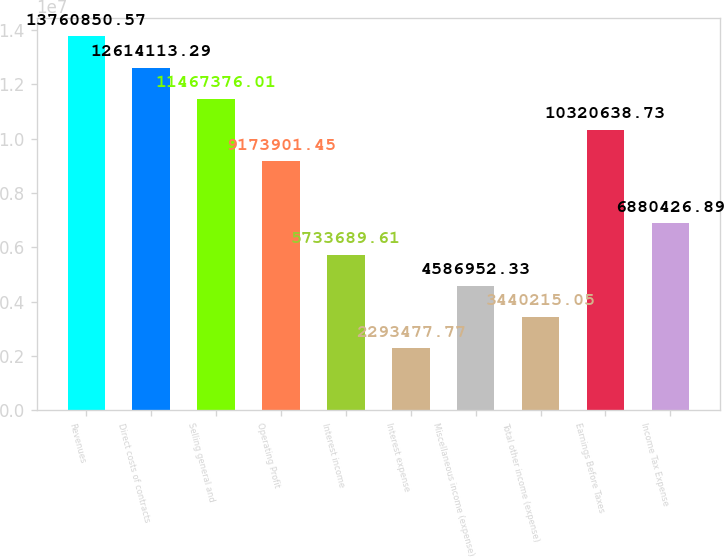<chart> <loc_0><loc_0><loc_500><loc_500><bar_chart><fcel>Revenues<fcel>Direct costs of contracts<fcel>Selling general and<fcel>Operating Profit<fcel>Interest income<fcel>Interest expense<fcel>Miscellaneous income (expense)<fcel>Total other income (expense)<fcel>Earnings Before Taxes<fcel>Income Tax Expense<nl><fcel>1.37609e+07<fcel>1.26141e+07<fcel>1.14674e+07<fcel>9.1739e+06<fcel>5.73369e+06<fcel>2.29348e+06<fcel>4.58695e+06<fcel>3.44022e+06<fcel>1.03206e+07<fcel>6.88043e+06<nl></chart> 